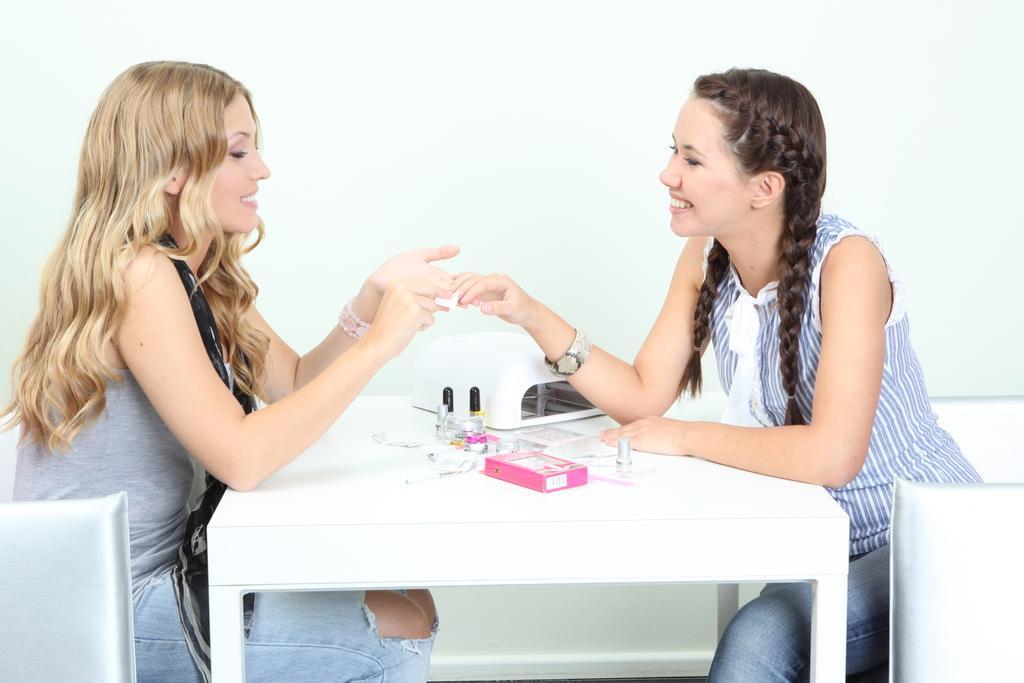Describe this image in one or two sentences. In the image we can see there are two woman who are sitting on chair and on table there are nail polish, pink colour cardboard box. 